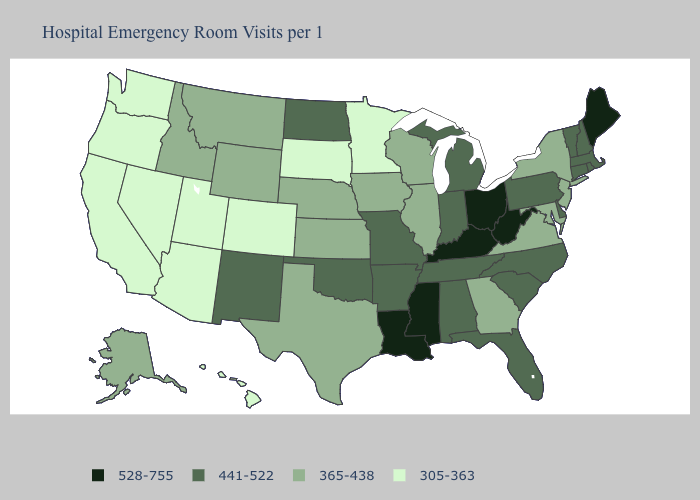Name the states that have a value in the range 441-522?
Quick response, please. Alabama, Arkansas, Connecticut, Delaware, Florida, Indiana, Massachusetts, Michigan, Missouri, New Hampshire, New Mexico, North Carolina, North Dakota, Oklahoma, Pennsylvania, Rhode Island, South Carolina, Tennessee, Vermont. Which states hav the highest value in the MidWest?
Concise answer only. Ohio. What is the highest value in the MidWest ?
Write a very short answer. 528-755. Does Pennsylvania have a higher value than Iowa?
Short answer required. Yes. Name the states that have a value in the range 365-438?
Be succinct. Alaska, Georgia, Idaho, Illinois, Iowa, Kansas, Maryland, Montana, Nebraska, New Jersey, New York, Texas, Virginia, Wisconsin, Wyoming. What is the highest value in the USA?
Keep it brief. 528-755. Does North Carolina have the lowest value in the South?
Give a very brief answer. No. Name the states that have a value in the range 441-522?
Be succinct. Alabama, Arkansas, Connecticut, Delaware, Florida, Indiana, Massachusetts, Michigan, Missouri, New Hampshire, New Mexico, North Carolina, North Dakota, Oklahoma, Pennsylvania, Rhode Island, South Carolina, Tennessee, Vermont. Does the map have missing data?
Answer briefly. No. Name the states that have a value in the range 305-363?
Write a very short answer. Arizona, California, Colorado, Hawaii, Minnesota, Nevada, Oregon, South Dakota, Utah, Washington. Name the states that have a value in the range 441-522?
Write a very short answer. Alabama, Arkansas, Connecticut, Delaware, Florida, Indiana, Massachusetts, Michigan, Missouri, New Hampshire, New Mexico, North Carolina, North Dakota, Oklahoma, Pennsylvania, Rhode Island, South Carolina, Tennessee, Vermont. Name the states that have a value in the range 365-438?
Quick response, please. Alaska, Georgia, Idaho, Illinois, Iowa, Kansas, Maryland, Montana, Nebraska, New Jersey, New York, Texas, Virginia, Wisconsin, Wyoming. What is the value of Wyoming?
Answer briefly. 365-438. Name the states that have a value in the range 528-755?
Answer briefly. Kentucky, Louisiana, Maine, Mississippi, Ohio, West Virginia. 